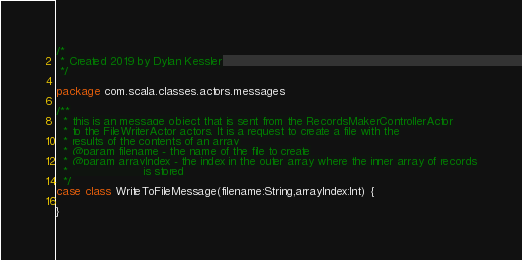Convert code to text. <code><loc_0><loc_0><loc_500><loc_500><_Scala_>/*
 * Created 2019 by Dylan Kessler
 */

package com.scala.classes.actors.messages

/**
  * this is an message object that is sent from the RecordsMakerControllerActor
  * to the FileWriterActor actors. It is a request to create a file with the
  * results of the contents of an array
  * @param filename - the name of the file to create
  * @param arrayIndex - the index in the outer array where the inner array of records
  *                     is stored
  */
case class WriteToFileMessage(filename:String,arrayIndex:Int) {

}
</code> 